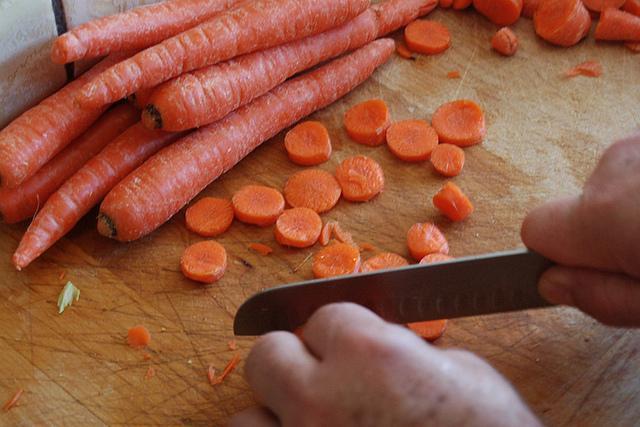How many carrots can be seen?
Give a very brief answer. 4. How many of the people on the bench are holding umbrellas ?
Give a very brief answer. 0. 